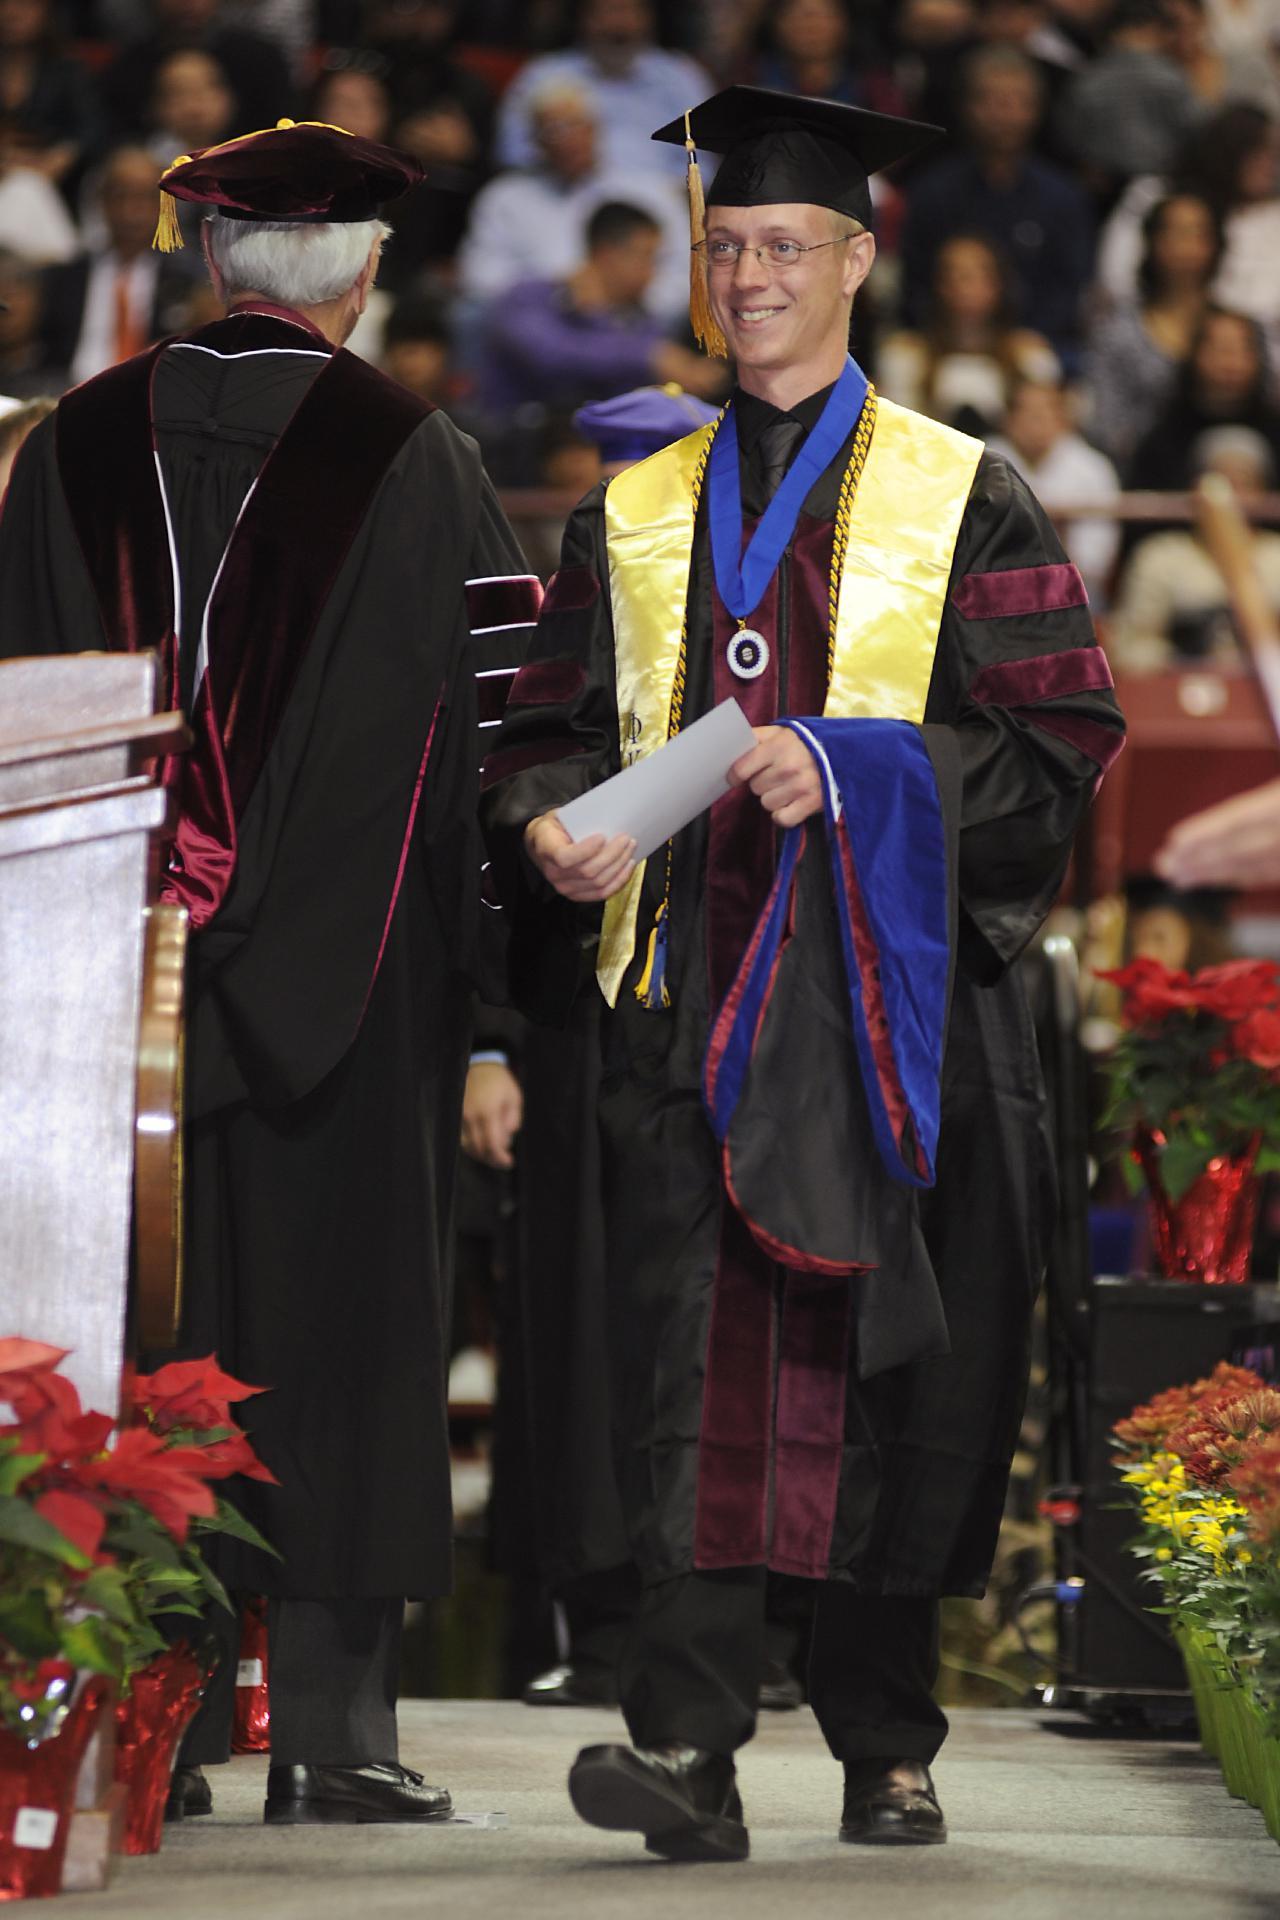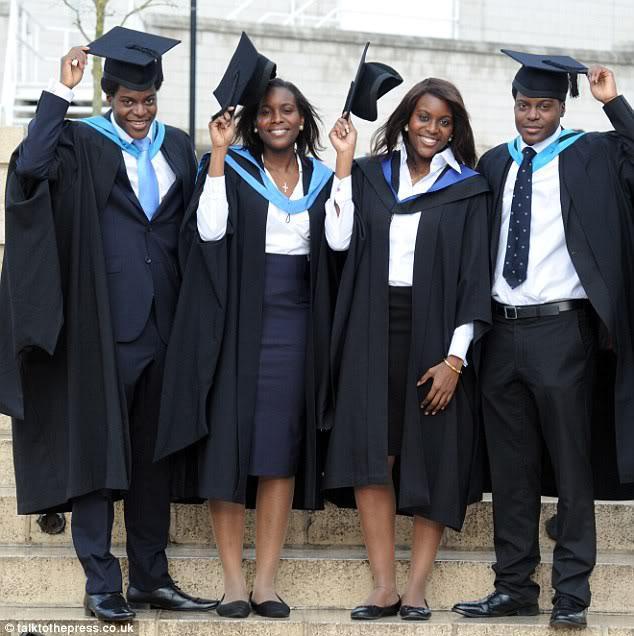The first image is the image on the left, the second image is the image on the right. Evaluate the accuracy of this statement regarding the images: "There are at least two white shirt fronts visible in the image on the right". Is it true? Answer yes or no. Yes. The first image is the image on the left, the second image is the image on the right. Examine the images to the left and right. Is the description "There are at least two girls outside in one of the images." accurate? Answer yes or no. Yes. 